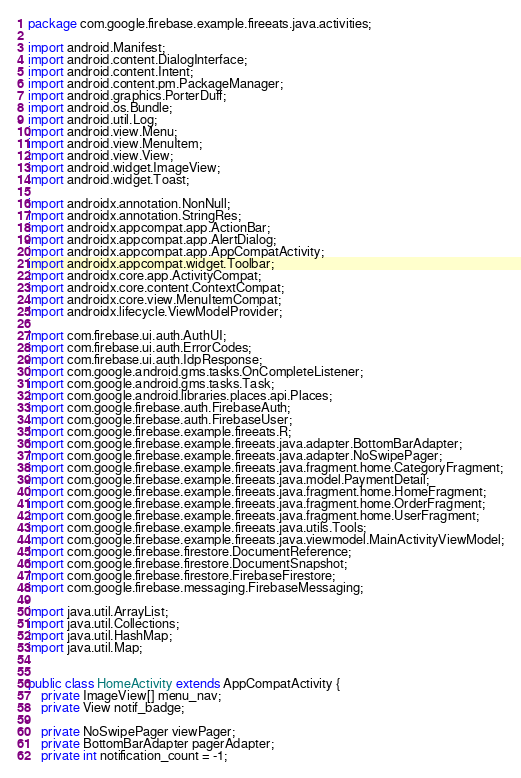Convert code to text. <code><loc_0><loc_0><loc_500><loc_500><_Java_>package com.google.firebase.example.fireeats.java.activities;

import android.Manifest;
import android.content.DialogInterface;
import android.content.Intent;
import android.content.pm.PackageManager;
import android.graphics.PorterDuff;
import android.os.Bundle;
import android.util.Log;
import android.view.Menu;
import android.view.MenuItem;
import android.view.View;
import android.widget.ImageView;
import android.widget.Toast;

import androidx.annotation.NonNull;
import androidx.annotation.StringRes;
import androidx.appcompat.app.ActionBar;
import androidx.appcompat.app.AlertDialog;
import androidx.appcompat.app.AppCompatActivity;
import androidx.appcompat.widget.Toolbar;
import androidx.core.app.ActivityCompat;
import androidx.core.content.ContextCompat;
import androidx.core.view.MenuItemCompat;
import androidx.lifecycle.ViewModelProvider;

import com.firebase.ui.auth.AuthUI;
import com.firebase.ui.auth.ErrorCodes;
import com.firebase.ui.auth.IdpResponse;
import com.google.android.gms.tasks.OnCompleteListener;
import com.google.android.gms.tasks.Task;
import com.google.android.libraries.places.api.Places;
import com.google.firebase.auth.FirebaseAuth;
import com.google.firebase.auth.FirebaseUser;
import com.google.firebase.example.fireeats.R;
import com.google.firebase.example.fireeats.java.adapter.BottomBarAdapter;
import com.google.firebase.example.fireeats.java.adapter.NoSwipePager;
import com.google.firebase.example.fireeats.java.fragment.home.CategoryFragment;
import com.google.firebase.example.fireeats.java.model.PaymentDetail;
import com.google.firebase.example.fireeats.java.fragment.home.HomeFragment;
import com.google.firebase.example.fireeats.java.fragment.home.OrderFragment;
import com.google.firebase.example.fireeats.java.fragment.home.UserFragment;
import com.google.firebase.example.fireeats.java.utils.Tools;
import com.google.firebase.example.fireeats.java.viewmodel.MainActivityViewModel;
import com.google.firebase.firestore.DocumentReference;
import com.google.firebase.firestore.DocumentSnapshot;
import com.google.firebase.firestore.FirebaseFirestore;
import com.google.firebase.messaging.FirebaseMessaging;

import java.util.ArrayList;
import java.util.Collections;
import java.util.HashMap;
import java.util.Map;


public class HomeActivity extends AppCompatActivity {
    private ImageView[] menu_nav;
    private View notif_badge;

    private NoSwipePager viewPager;
    private BottomBarAdapter pagerAdapter;
    private int notification_count = -1;</code> 